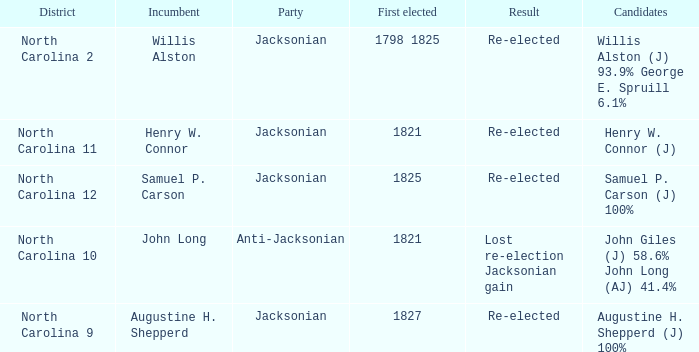1%. 1.0. 